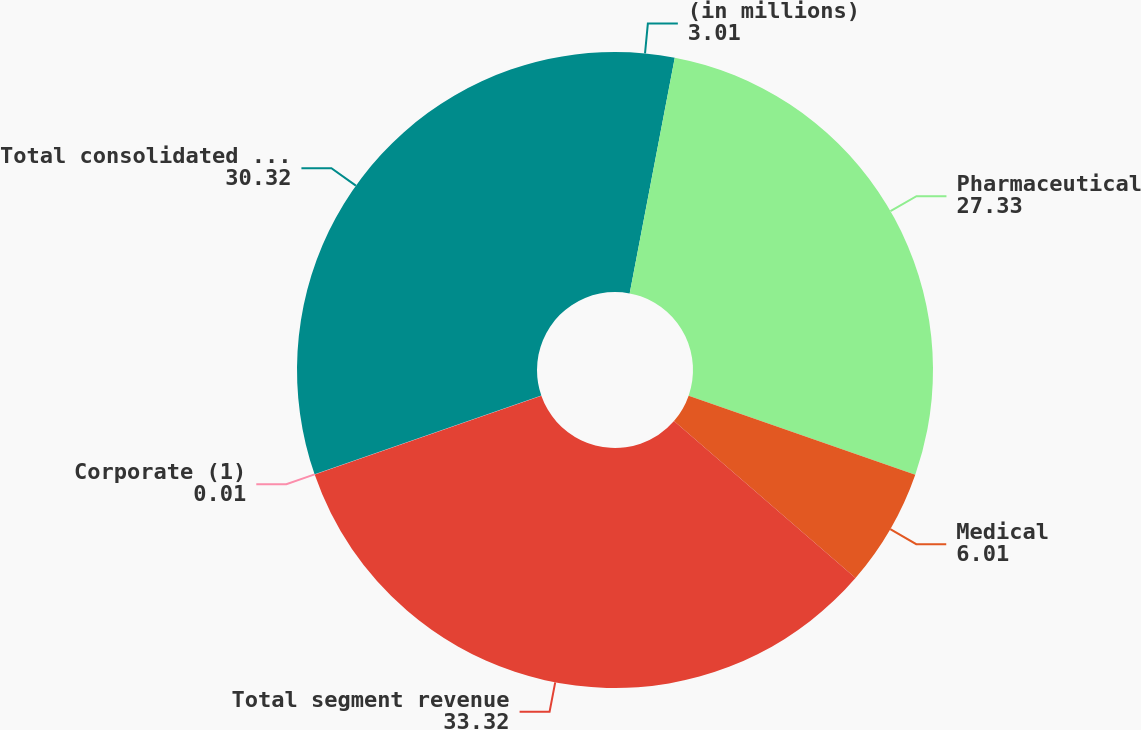Convert chart. <chart><loc_0><loc_0><loc_500><loc_500><pie_chart><fcel>(in millions)<fcel>Pharmaceutical<fcel>Medical<fcel>Total segment revenue<fcel>Corporate (1)<fcel>Total consolidated revenue<nl><fcel>3.01%<fcel>27.33%<fcel>6.01%<fcel>33.32%<fcel>0.01%<fcel>30.32%<nl></chart> 